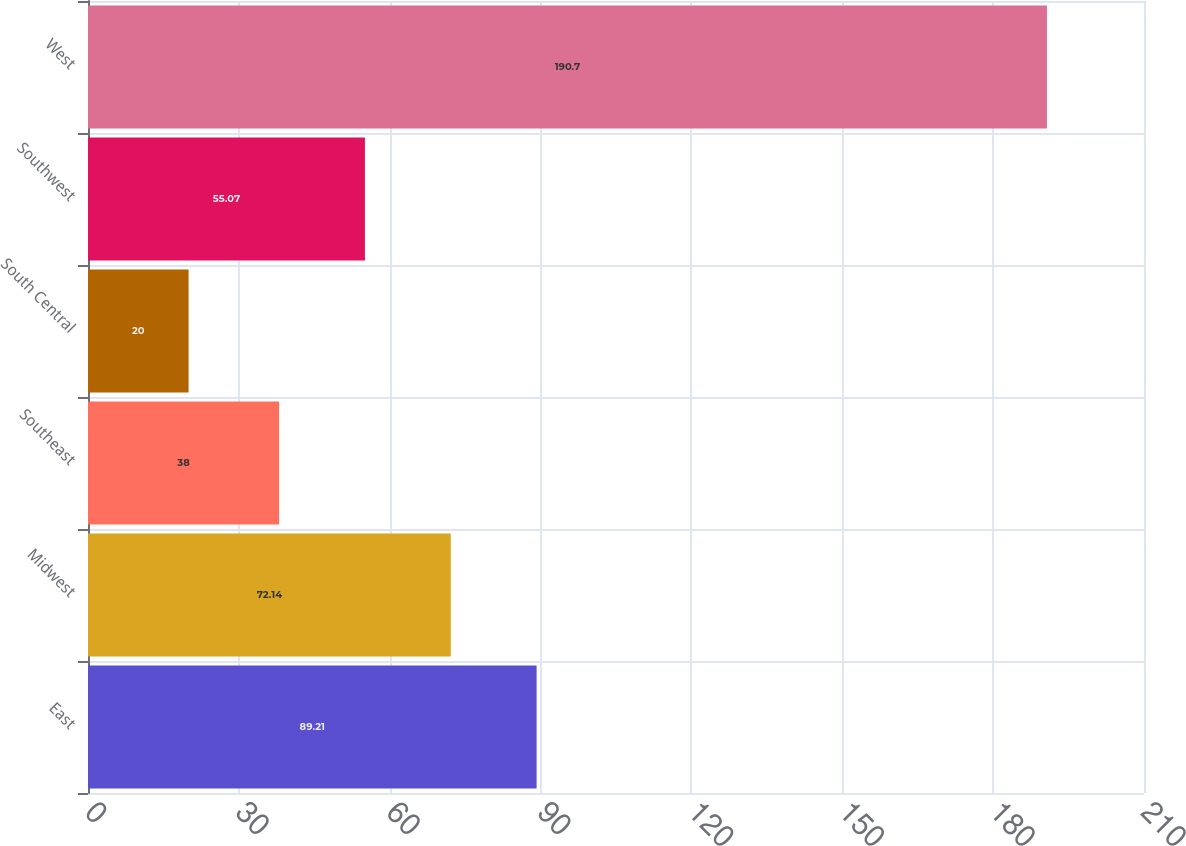Convert chart to OTSL. <chart><loc_0><loc_0><loc_500><loc_500><bar_chart><fcel>East<fcel>Midwest<fcel>Southeast<fcel>South Central<fcel>Southwest<fcel>West<nl><fcel>89.21<fcel>72.14<fcel>38<fcel>20<fcel>55.07<fcel>190.7<nl></chart> 